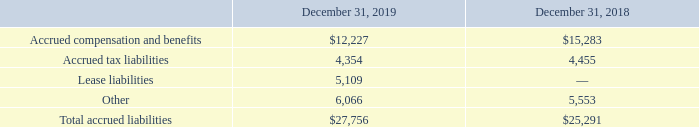Accrued Liabilities
Accrued liabilities consisted of the following (in thousands):
What is the total accrued liabilities as at 31 December 2018?
Answer scale should be: thousand. $25,291. What is the total accrued liabilities as at 31 December 2019?
Answer scale should be: thousand. $27,756. What is the units that the values in the table are measured in? In thousands. What is the percentage change in total accrued liabilities between 2018 and 2019?
Answer scale should be: percent. (27,756 - 25,291)/25,291 
Answer: 9.75. What is the percentage change in total accrued liabilities between 2018 and 2019?
Answer scale should be: thousand. 27,756-25,291
Answer: 2465. What is the total accrued tax liabilities between 2018 and 2019?
Answer scale should be: thousand. 4,354 + 4,455 
Answer: 8809. 